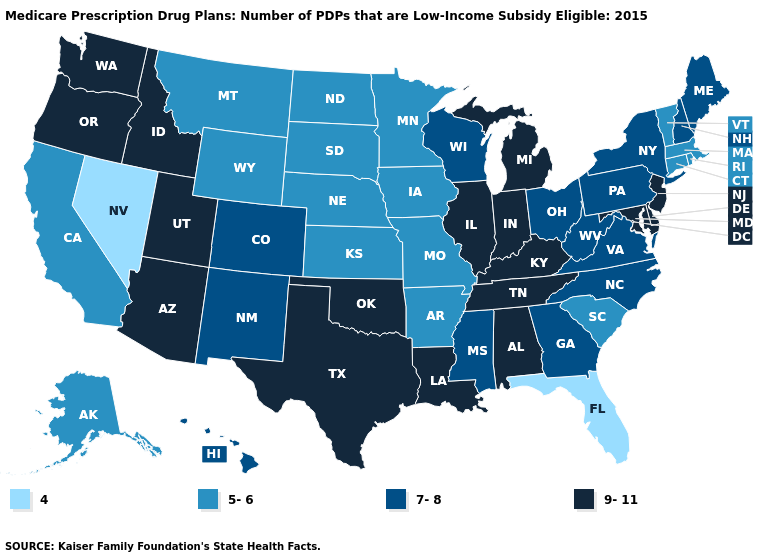Name the states that have a value in the range 4?
Answer briefly. Florida, Nevada. Name the states that have a value in the range 4?
Write a very short answer. Florida, Nevada. Name the states that have a value in the range 5-6?
Answer briefly. Alaska, Arkansas, California, Connecticut, Iowa, Kansas, Massachusetts, Minnesota, Missouri, Montana, North Dakota, Nebraska, Rhode Island, South Carolina, South Dakota, Vermont, Wyoming. Which states have the lowest value in the USA?
Concise answer only. Florida, Nevada. What is the value of Tennessee?
Keep it brief. 9-11. Name the states that have a value in the range 9-11?
Write a very short answer. Alabama, Arizona, Delaware, Idaho, Illinois, Indiana, Kentucky, Louisiana, Maryland, Michigan, New Jersey, Oklahoma, Oregon, Tennessee, Texas, Utah, Washington. Does Illinois have the highest value in the MidWest?
Quick response, please. Yes. What is the value of Iowa?
Give a very brief answer. 5-6. Is the legend a continuous bar?
Answer briefly. No. What is the value of New Hampshire?
Quick response, please. 7-8. Does Florida have the lowest value in the USA?
Short answer required. Yes. Among the states that border Connecticut , does Massachusetts have the highest value?
Answer briefly. No. Does Nevada have the lowest value in the USA?
Write a very short answer. Yes. Name the states that have a value in the range 4?
Answer briefly. Florida, Nevada. What is the value of Kentucky?
Give a very brief answer. 9-11. 